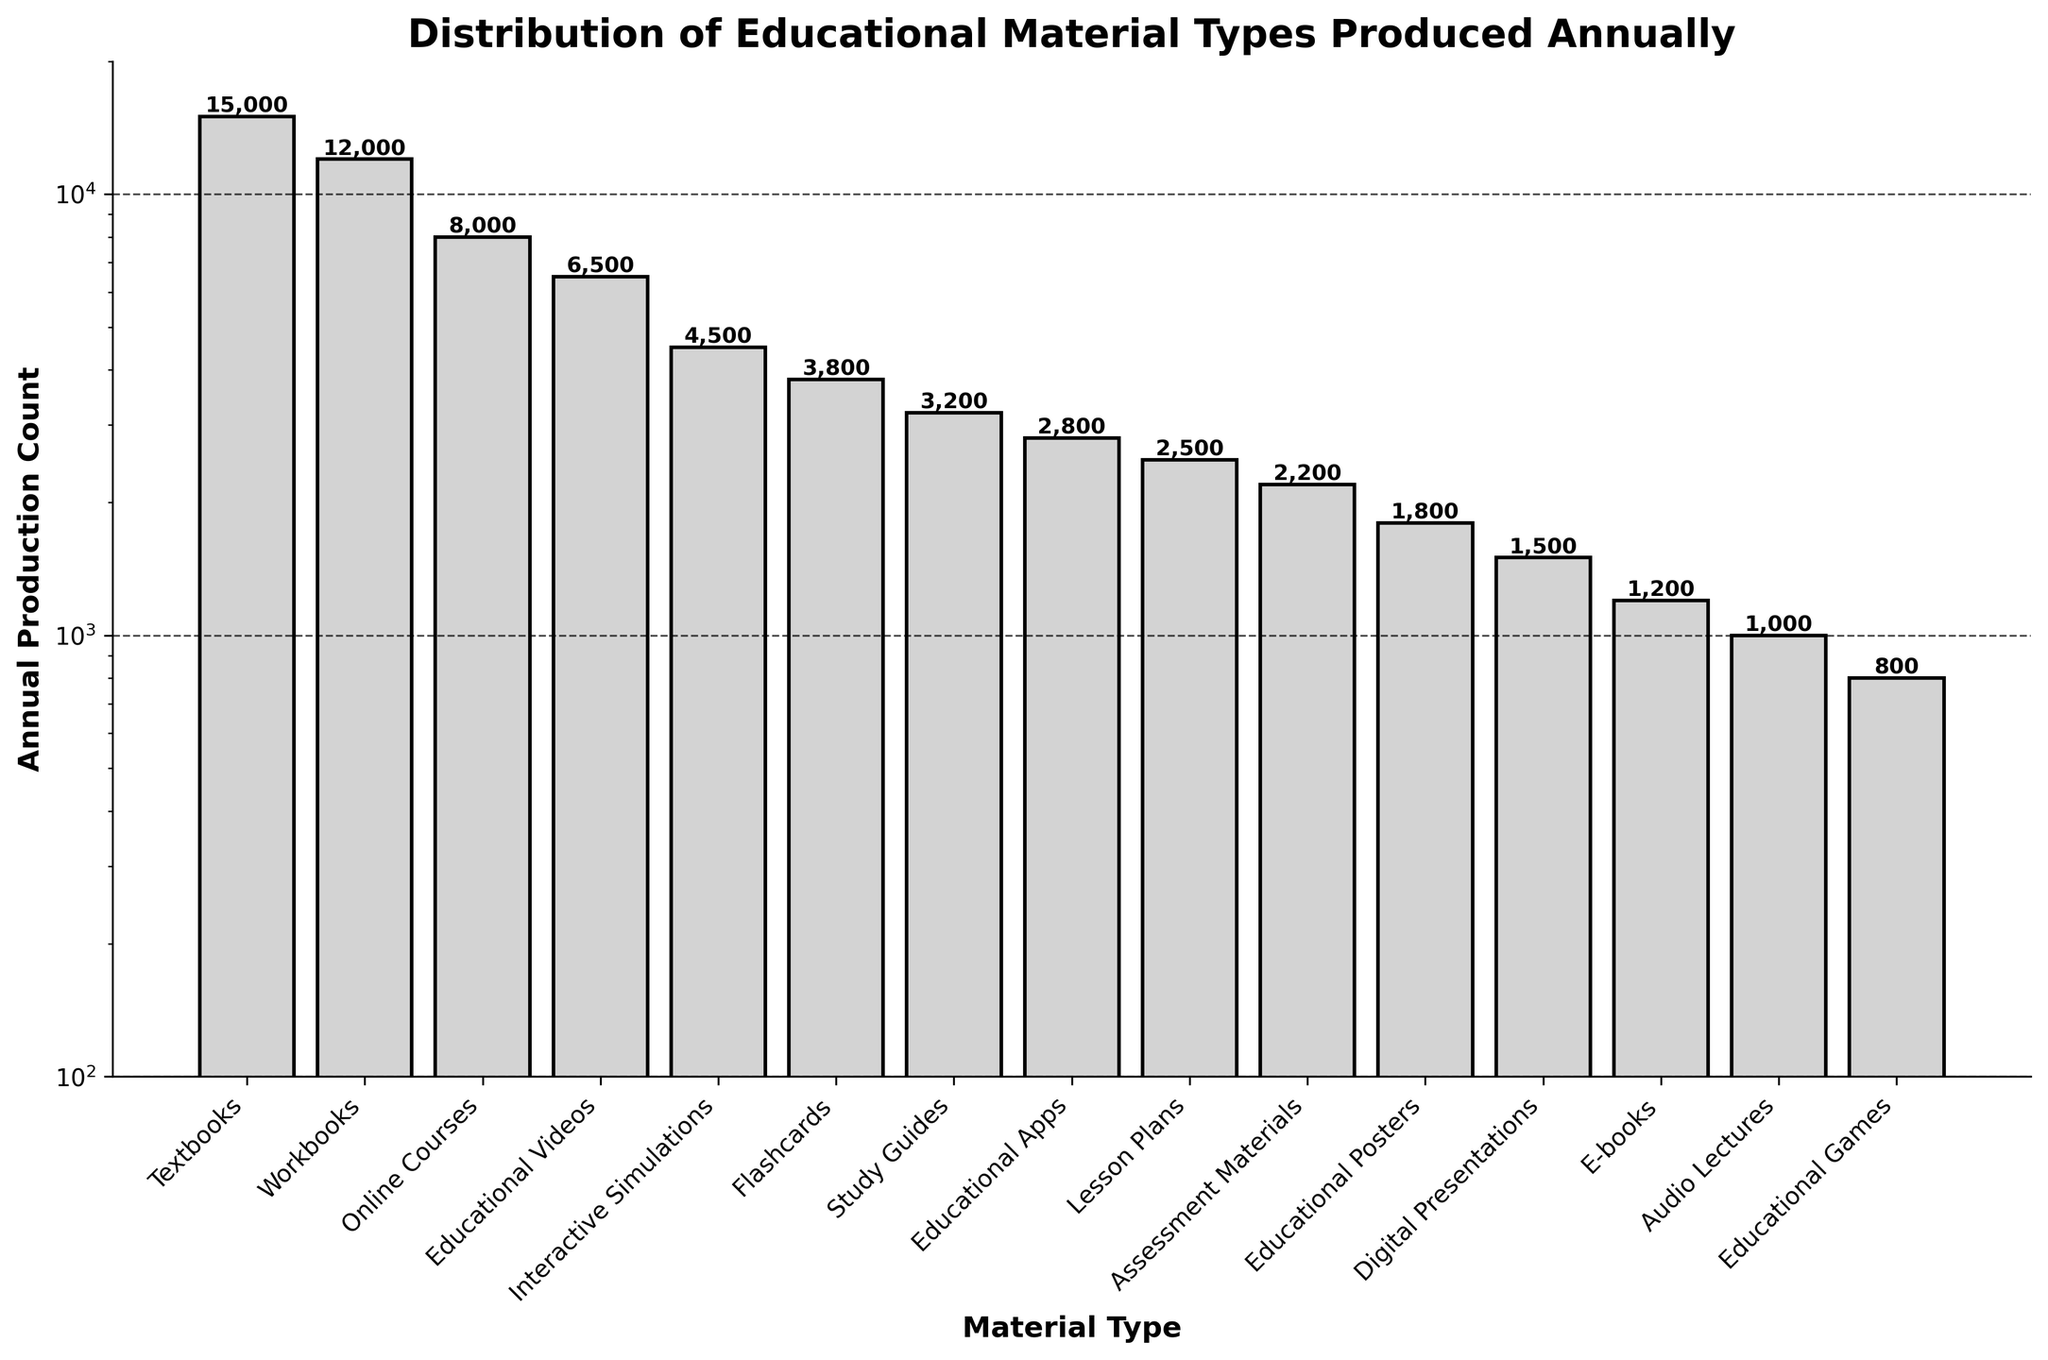What's the most produced educational material type annually? The tallest bar represents the material type with the highest production count, which is Textbooks.
Answer: Textbooks Which educational material type has the lowest annual production count? The shortest bar indicates the material type with the lowest production count, which is Educational Games.
Answer: Educational Games What's the total production count of Textbooks and Workbooks combined annually? Add the production counts of Textbooks (15,000) and Workbooks (12,000). The sum is 15,000 + 12,000 = 27,000.
Answer: 27,000 How much larger is the production count of Online Courses compared to Educational Videos annually? Subtract the production count of Educational Videos (6,500) from that of Online Courses (8,000): 8,000 - 6,500 = 1,500.
Answer: 1,500 How does the production count of Educational Videos compare to Study Guides? Educational Videos have a production count of 6,500, while Study Guides have 3,200. Since 6,500 is greater than 3,200, Educational Videos have a higher production count.
Answer: Educational Videos have a higher production count Which material type has a production count closest to 4,000? The material type with a production count closest to 4,000 is Flashcards, which have a count of 3,800.
Answer: Flashcards How many educational material types have an annual production count greater than 5,000? Count all material types with production counts above 5,000: Textbooks (15,000), Workbooks (12,000), Online Courses (8,000), and Educational Videos (6,500). There are four in total.
Answer: 4 What is the average annual production count of Digital Presentations, E-books, and Audio Lectures? Add the production counts (1,500 for Digital Presentations, 1,200 for E-books, and 1,000 for Audio Lectures) and divide by 3: (1,500 + 1,200 + 1,000) / 3 = 1,233.33.
Answer: 1,233.33 Which material type has an annual production count that is a factor of 10 less than Textbooks? Textbooks have a production count of 15,000. The material type with a count close to 15,000 / 10 = 1,500 is Digital Presentations with 1,500.
Answer: Digital Presentations 